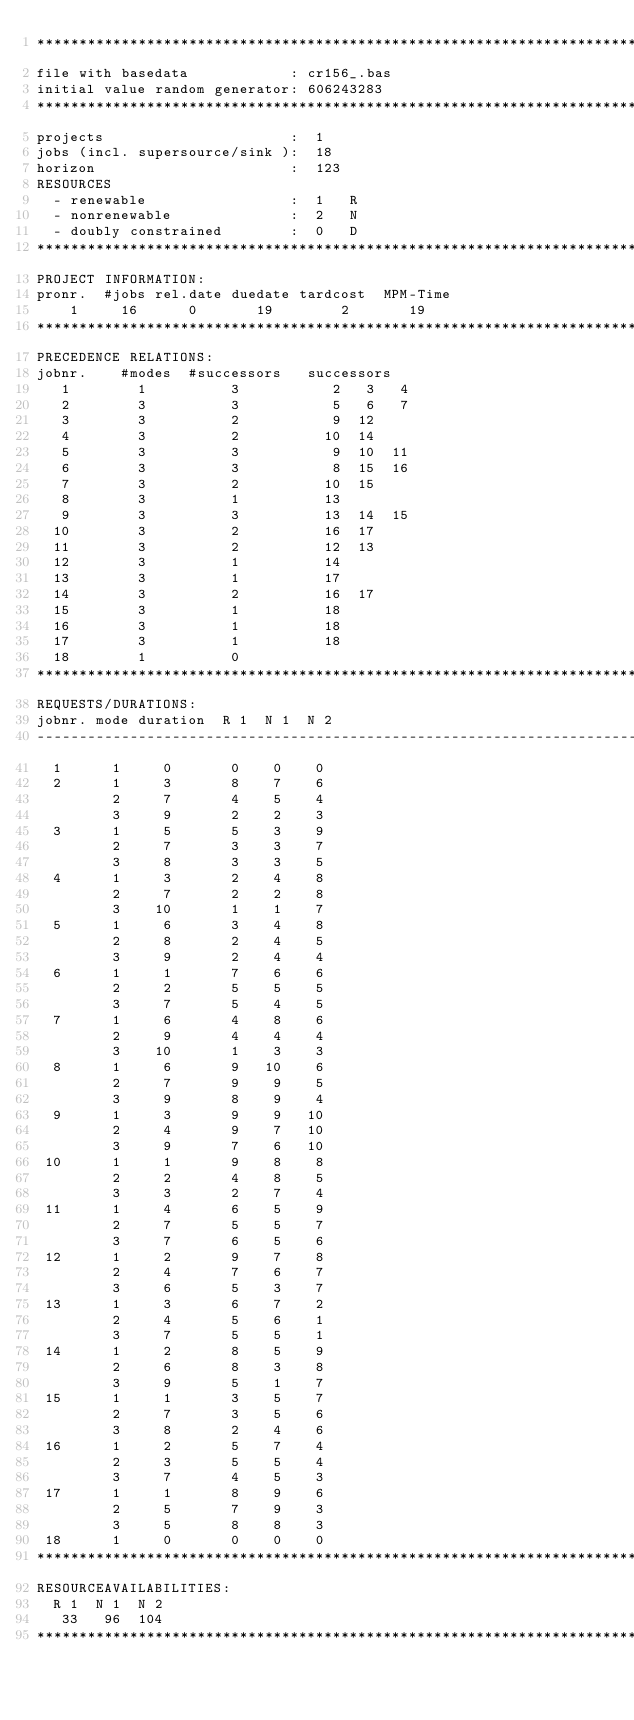<code> <loc_0><loc_0><loc_500><loc_500><_ObjectiveC_>************************************************************************
file with basedata            : cr156_.bas
initial value random generator: 606243283
************************************************************************
projects                      :  1
jobs (incl. supersource/sink ):  18
horizon                       :  123
RESOURCES
  - renewable                 :  1   R
  - nonrenewable              :  2   N
  - doubly constrained        :  0   D
************************************************************************
PROJECT INFORMATION:
pronr.  #jobs rel.date duedate tardcost  MPM-Time
    1     16      0       19        2       19
************************************************************************
PRECEDENCE RELATIONS:
jobnr.    #modes  #successors   successors
   1        1          3           2   3   4
   2        3          3           5   6   7
   3        3          2           9  12
   4        3          2          10  14
   5        3          3           9  10  11
   6        3          3           8  15  16
   7        3          2          10  15
   8        3          1          13
   9        3          3          13  14  15
  10        3          2          16  17
  11        3          2          12  13
  12        3          1          14
  13        3          1          17
  14        3          2          16  17
  15        3          1          18
  16        3          1          18
  17        3          1          18
  18        1          0        
************************************************************************
REQUESTS/DURATIONS:
jobnr. mode duration  R 1  N 1  N 2
------------------------------------------------------------------------
  1      1     0       0    0    0
  2      1     3       8    7    6
         2     7       4    5    4
         3     9       2    2    3
  3      1     5       5    3    9
         2     7       3    3    7
         3     8       3    3    5
  4      1     3       2    4    8
         2     7       2    2    8
         3    10       1    1    7
  5      1     6       3    4    8
         2     8       2    4    5
         3     9       2    4    4
  6      1     1       7    6    6
         2     2       5    5    5
         3     7       5    4    5
  7      1     6       4    8    6
         2     9       4    4    4
         3    10       1    3    3
  8      1     6       9   10    6
         2     7       9    9    5
         3     9       8    9    4
  9      1     3       9    9   10
         2     4       9    7   10
         3     9       7    6   10
 10      1     1       9    8    8
         2     2       4    8    5
         3     3       2    7    4
 11      1     4       6    5    9
         2     7       5    5    7
         3     7       6    5    6
 12      1     2       9    7    8
         2     4       7    6    7
         3     6       5    3    7
 13      1     3       6    7    2
         2     4       5    6    1
         3     7       5    5    1
 14      1     2       8    5    9
         2     6       8    3    8
         3     9       5    1    7
 15      1     1       3    5    7
         2     7       3    5    6
         3     8       2    4    6
 16      1     2       5    7    4
         2     3       5    5    4
         3     7       4    5    3
 17      1     1       8    9    6
         2     5       7    9    3
         3     5       8    8    3
 18      1     0       0    0    0
************************************************************************
RESOURCEAVAILABILITIES:
  R 1  N 1  N 2
   33   96  104
************************************************************************
</code> 